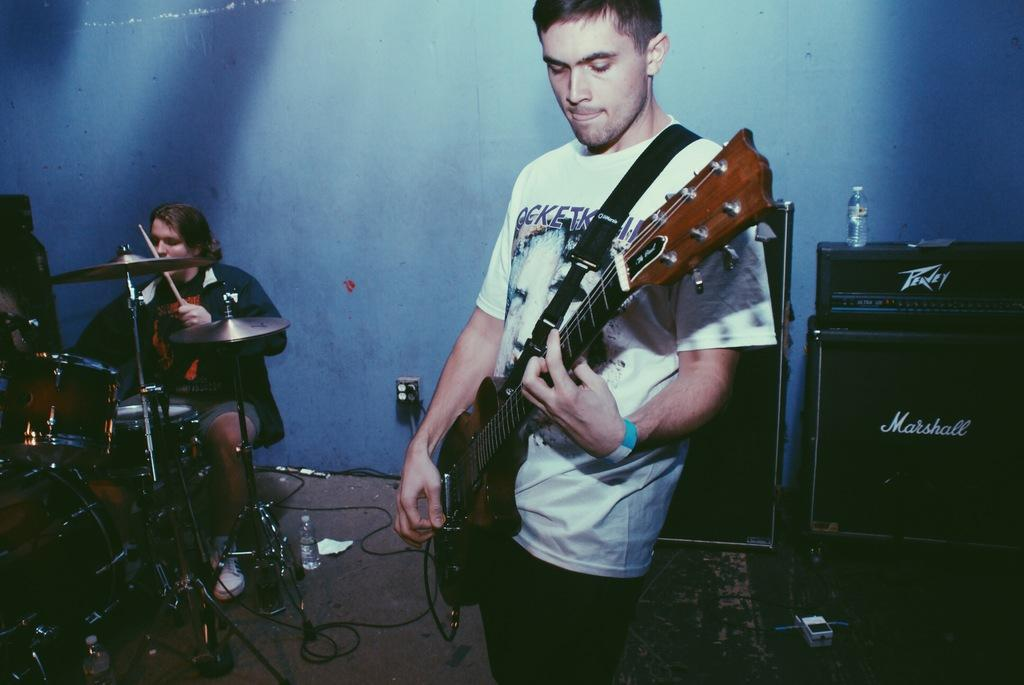How many people are in the image? There are two men in the image. What is one of the men holding? One man is holding a guitar. What is the other man doing in the image? The other man is sitting next to a drum set. What can be seen in the background of the image? There are speakers and a water bottle in the background of the image. What type of toe is visible on the drum in the image? There are no toes visible in the image, as it features two men and musical instruments, but no body parts other than hands. 